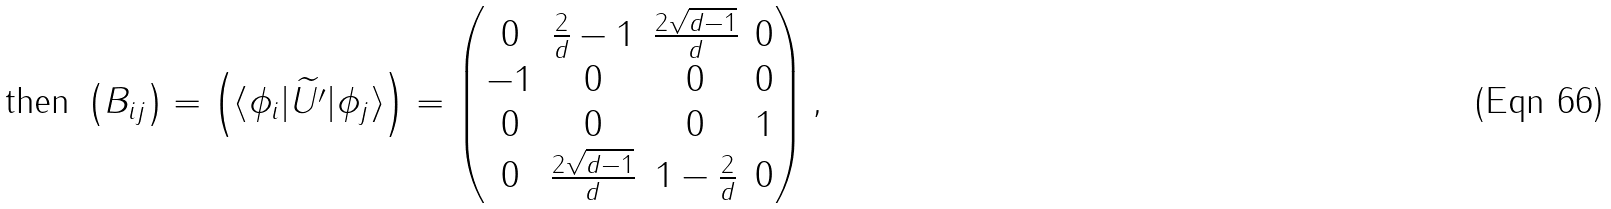Convert formula to latex. <formula><loc_0><loc_0><loc_500><loc_500>\text {then } \left ( B _ { i j } \right ) = \left ( \langle \phi _ { i } | \widetilde { U ^ { \prime } } | \phi _ { j } \rangle \right ) = \begin{pmatrix} 0 & \frac { 2 } { d } - 1 & \frac { 2 \sqrt { d - 1 } } { d } & 0 \\ - 1 & 0 & 0 & 0 \\ 0 & 0 & 0 & 1 \\ 0 & \frac { 2 \sqrt { d - 1 } } { d } & 1 - \frac { 2 } { d } & 0 \\ \end{pmatrix} ,</formula> 